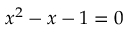Convert formula to latex. <formula><loc_0><loc_0><loc_500><loc_500>x ^ { 2 } - x - 1 = 0</formula> 